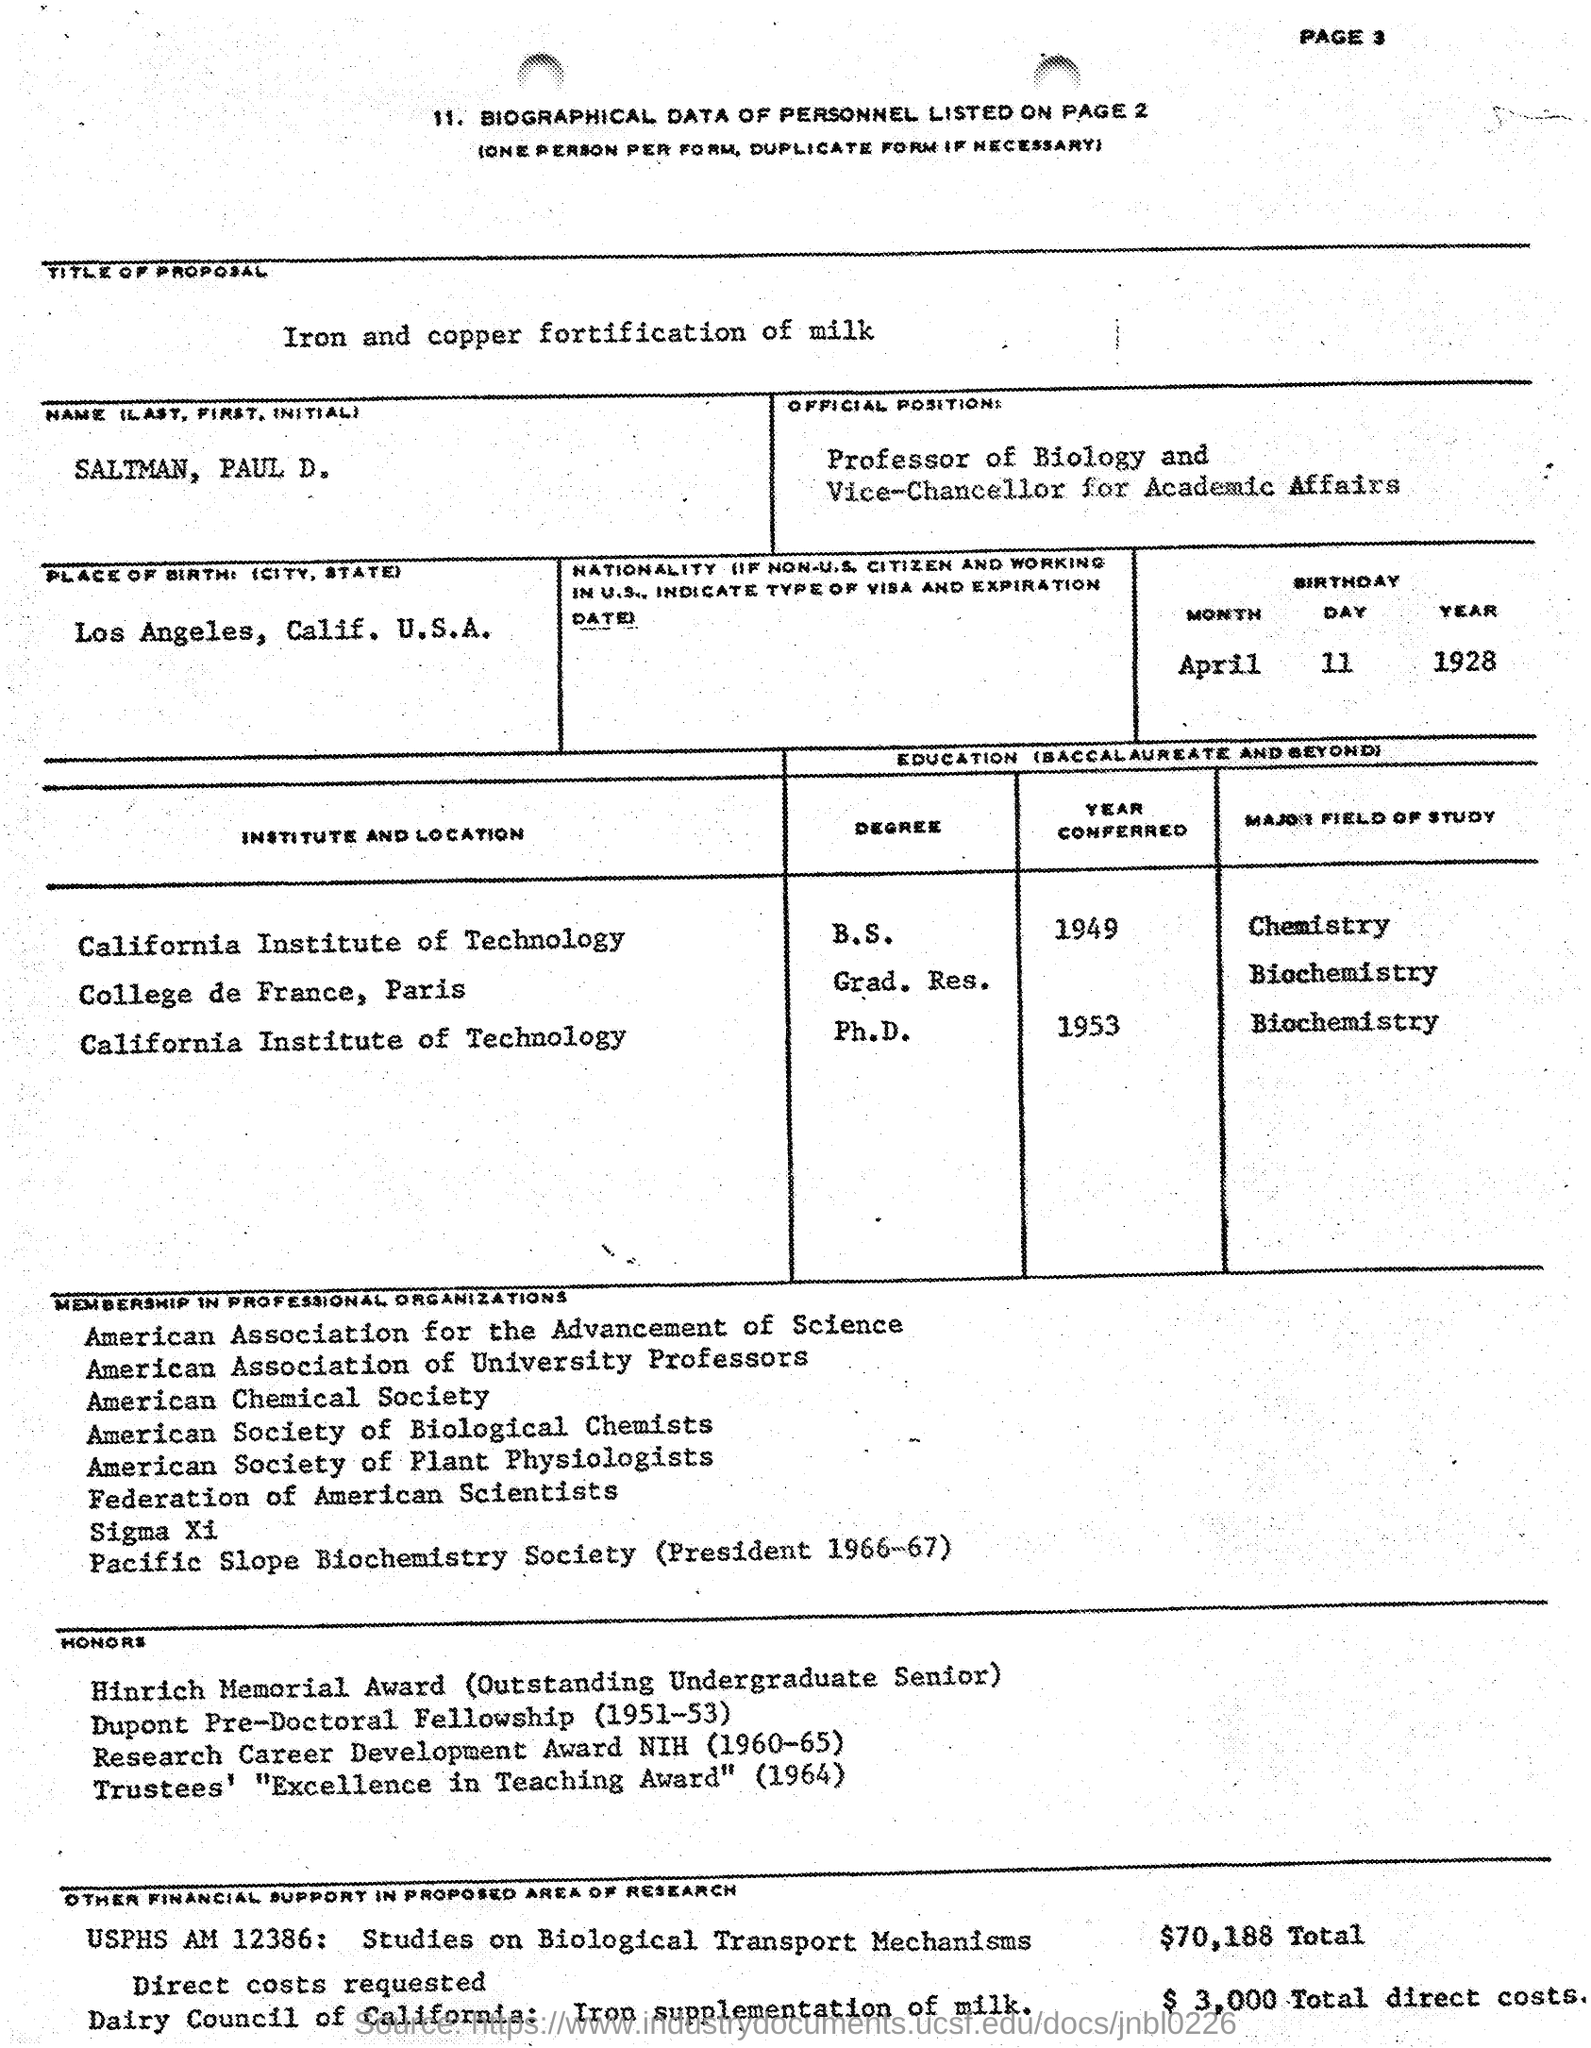What is the title of the proposal given in the document?
Your response must be concise. Iron and copper fortification of milk. What is the name of the person mentioned in the document?
Your answer should be very brief. SALTMAN, PAUL D. What is the date of birth of SALTMAN, PAUL D.?
Offer a terse response. April 11 1928. When did SALTMAN, PAUL D. completed B.S. degree in Chemistry from California Institue of Technology?
Keep it short and to the point. 1949. In which university, SALTMAN, PAUL D. completed Ph.D. in Biochemistry?
Make the answer very short. California Institute of Technology. Which award is won by SALTMAN, PAUL D. in the year 1964?
Your answer should be compact. TRUSTEES' "EXCELLENCE IN TEACHING AWARD". 